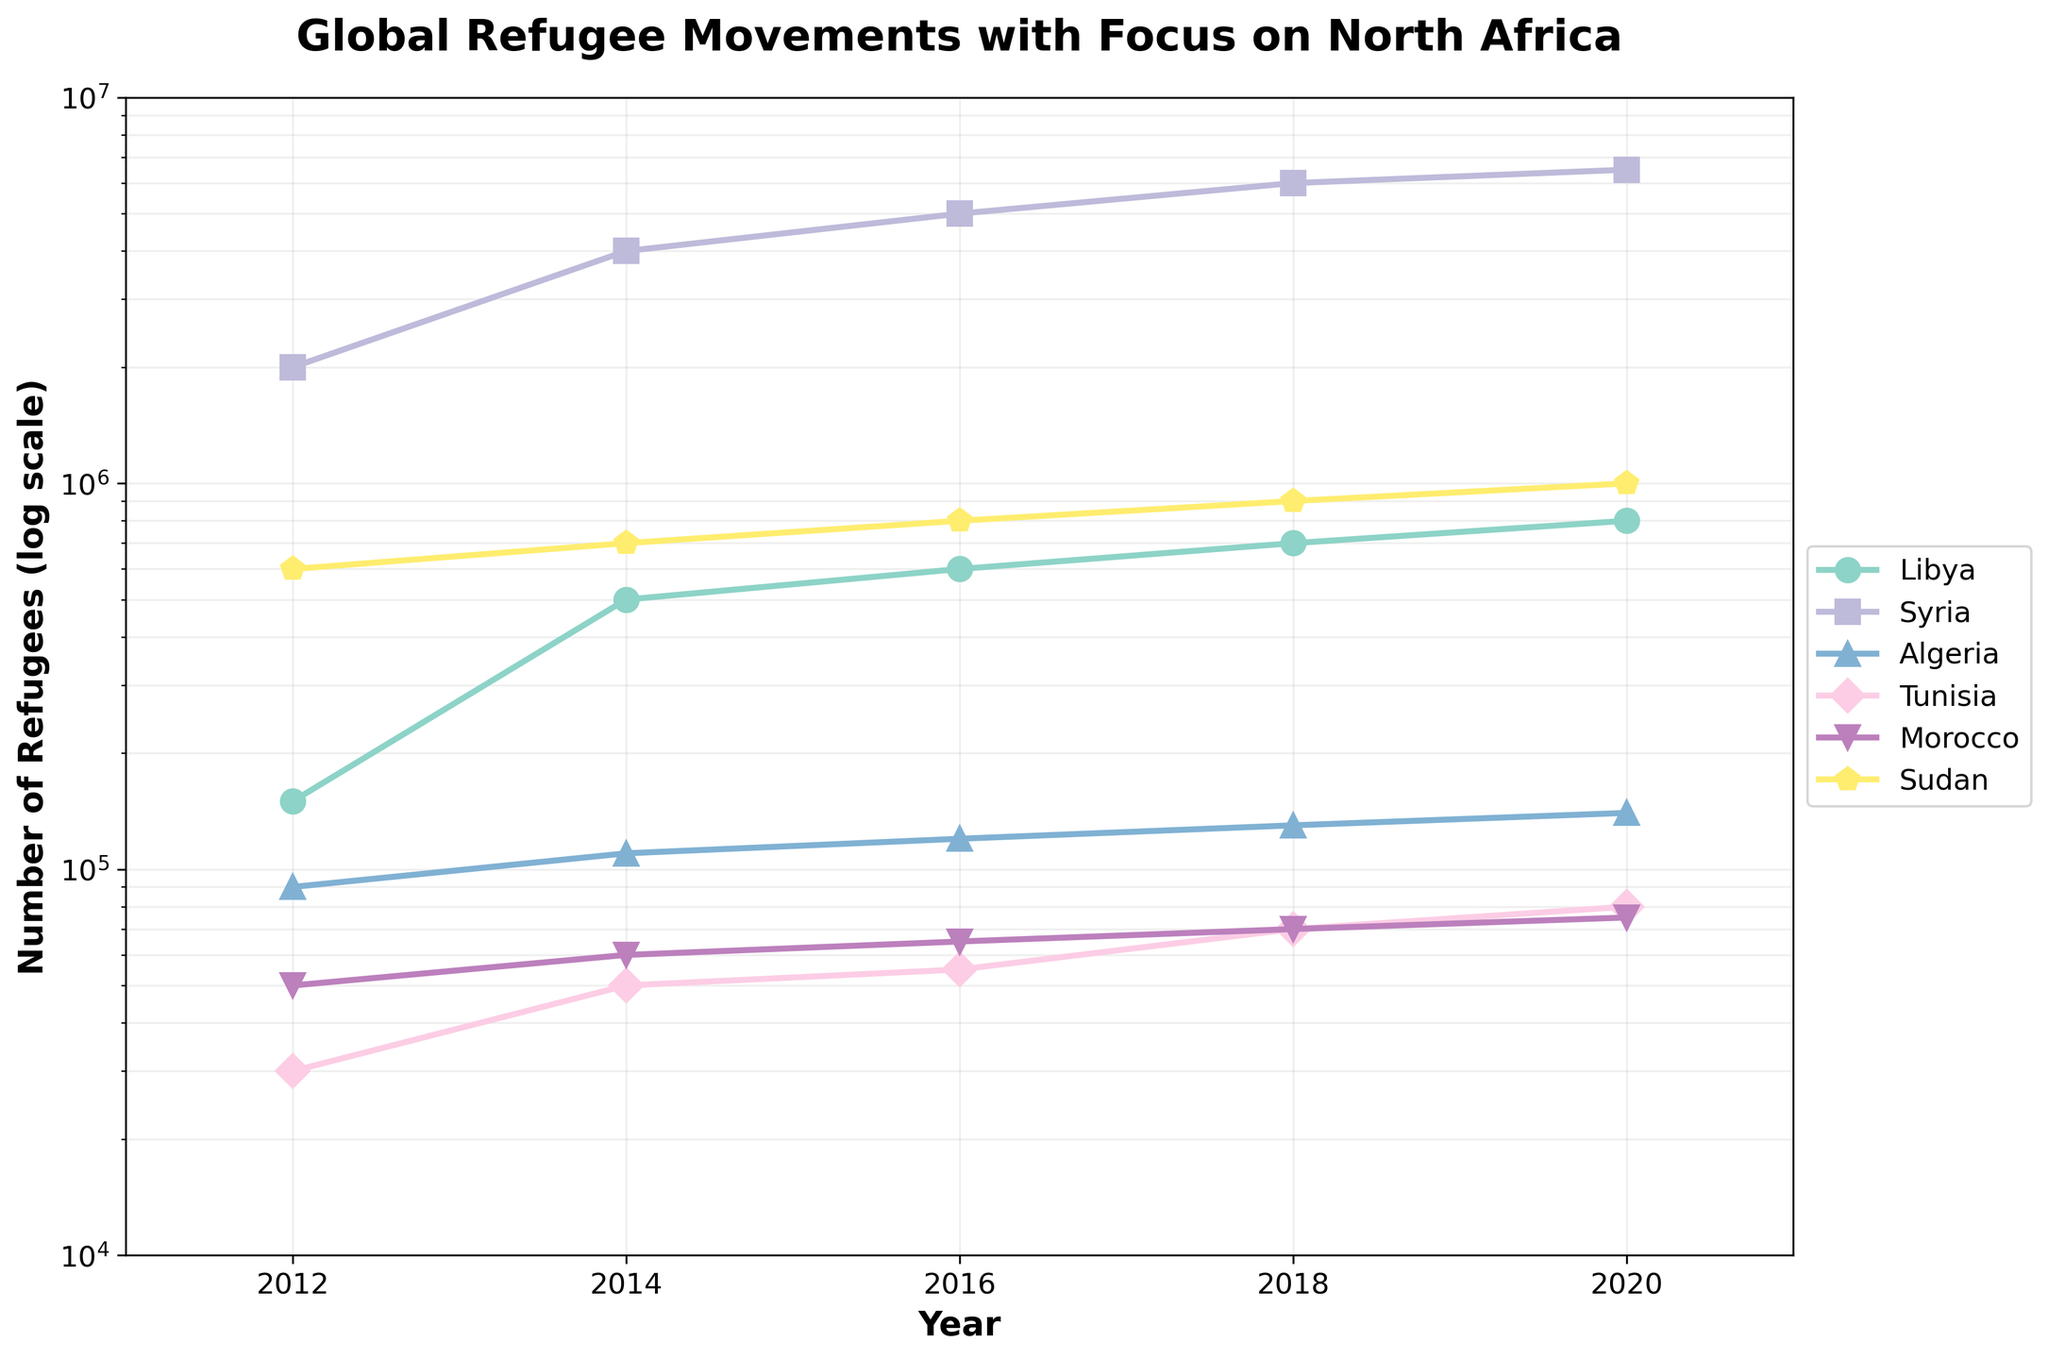What is the title of the plot? The plot's title is clearly displayed at the top.
Answer: "Global Refugee Movements with Focus on North Africa" What do the x-axis and y-axis represent? The x-axis represents the 'Year' from 2011 to 2021, and the y-axis represents the 'Number of Refugees' on a logarithmic scale.
Answer: Year and Number of Refugees (log scale) Which country has the highest number of refugees in 2020? The data points marked for the year 2020 can be compared, and the highest point corresponds to Syria.
Answer: Syria Between which years did Libya see the largest increase in the number of refugees? By observing the distance between data points for Libya across the years, we notice the largest increase between 2012 and 2014.
Answer: Between 2012 and 2014 How many countries are included in the plot? The legend lists all the countries represented in the plot.
Answer: Six (Libya, Syria, Algeria, Tunisia, Morocco, Sudan) Which country showed a consistent increase in the number of refugees from 2012 to 2020? By visually inspecting the trends of lines corresponding to each country, Sudan shows a consistent increase.
Answer: Sudan What is the approximate number of refugees from Morocco in 2018? On the logarithmic scale, locate Morocco’s point for 2018, which is at about 70,000.
Answer: 70,000 How does the number of refugees in Tunisia in 2020 compare to Algeria in 2020? By comparing their respective points on the plot, Tunisia has fewer refugees than Algeria in 2020.
Answer: Tunisia has fewer refugees than Algeria in 2020 Which country had the highest rate of increase in refugees between 2012 and 2014? By observing the slope of lines from 2012 to 2014, Syria had the steepest increase.
Answer: Syria What are the ranges for the x-axis and y-axis in the plot? The x-axis ranges from 2011 to 2021, and the y-axis ranges from 10,000 to 10,000,000 on a logarithmic scale.
Answer: 2011-2021 (x-axis), 10,000-10,000,000 (y-axis, log scale) 